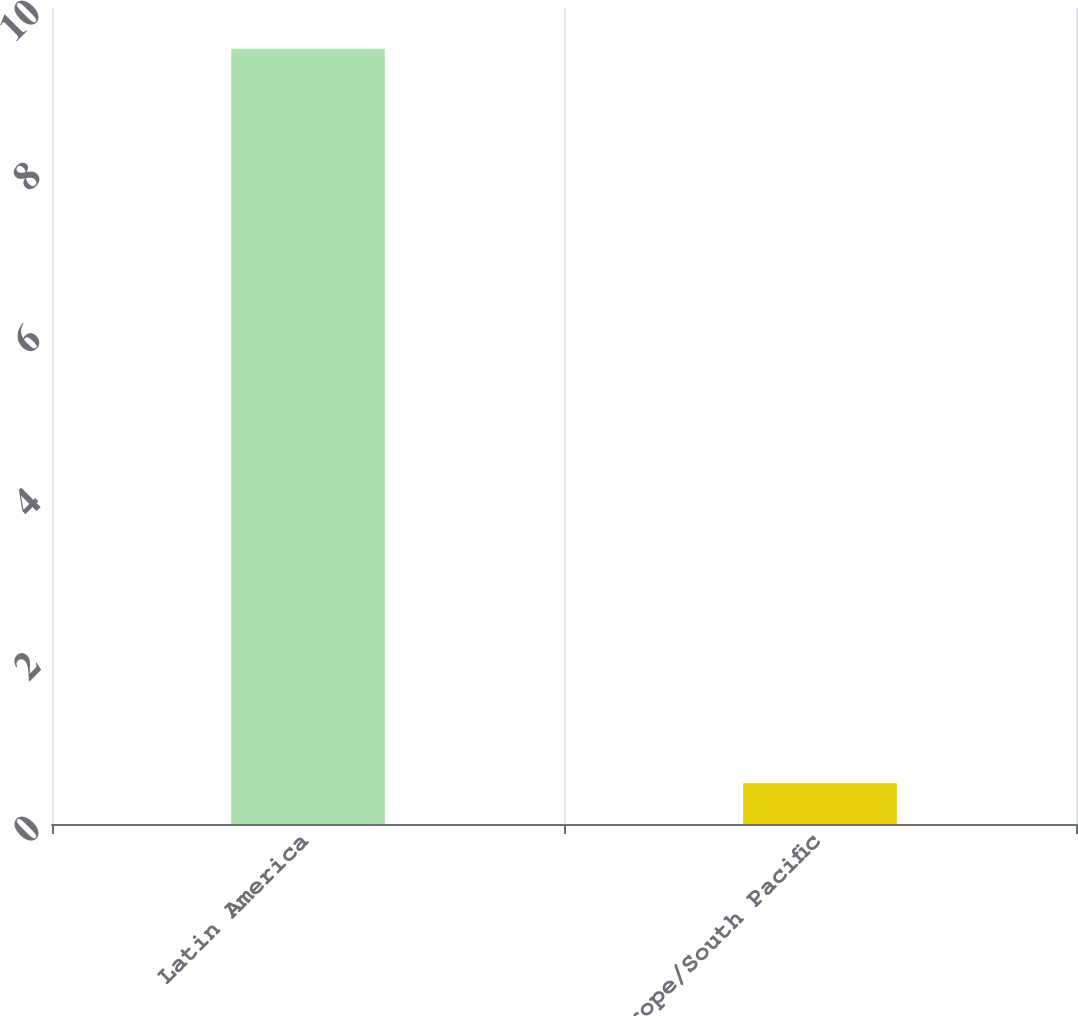Convert chart. <chart><loc_0><loc_0><loc_500><loc_500><bar_chart><fcel>Latin America<fcel>Europe/South Pacific<nl><fcel>9.5<fcel>0.5<nl></chart> 